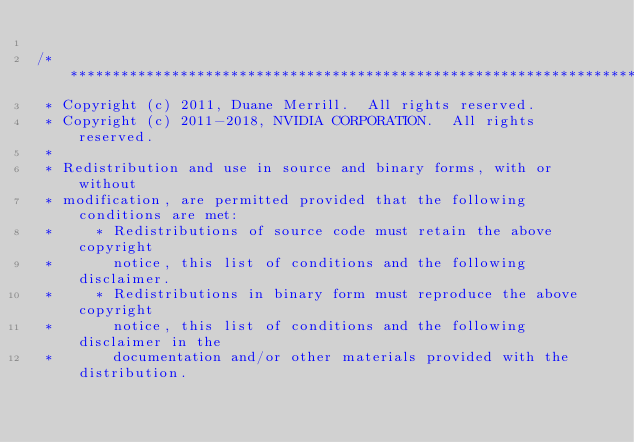Convert code to text. <code><loc_0><loc_0><loc_500><loc_500><_Cuda_>
/******************************************************************************
 * Copyright (c) 2011, Duane Merrill.  All rights reserved.
 * Copyright (c) 2011-2018, NVIDIA CORPORATION.  All rights reserved.
 *
 * Redistribution and use in source and binary forms, with or without
 * modification, are permitted provided that the following conditions are met:
 *     * Redistributions of source code must retain the above copyright
 *       notice, this list of conditions and the following disclaimer.
 *     * Redistributions in binary form must reproduce the above copyright
 *       notice, this list of conditions and the following disclaimer in the
 *       documentation and/or other materials provided with the distribution.</code> 